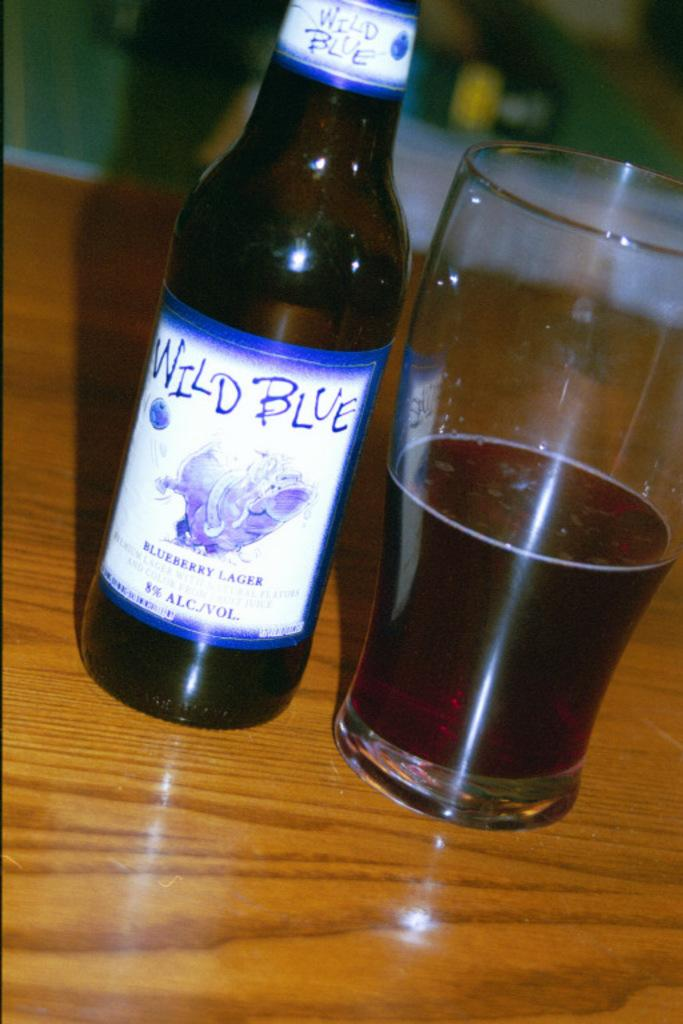<image>
Offer a succinct explanation of the picture presented. A bottle of Wild Blue Blueberry Lager next to a half full beer glass. 